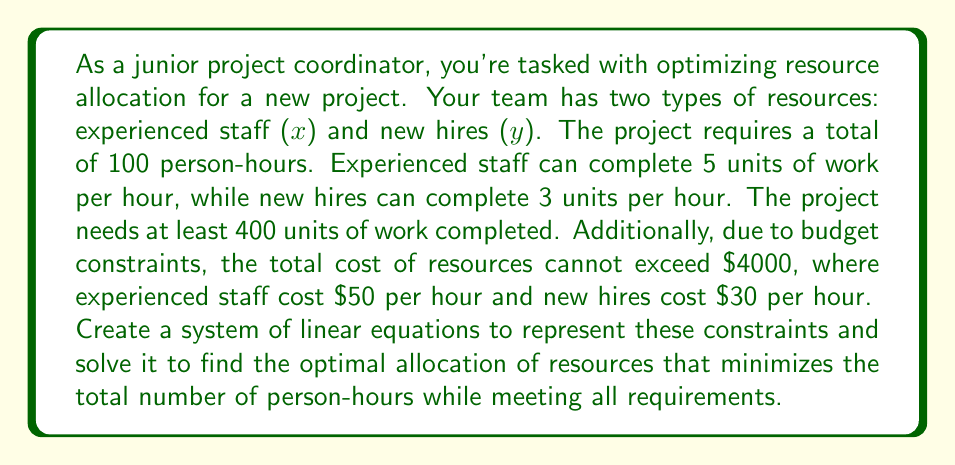Can you solve this math problem? Let's approach this step-by-step:

1) First, let's define our variables:
   $x$ = number of hours for experienced staff
   $y$ = number of hours for new hires

2) Now, let's create our system of linear equations based on the given constraints:

   a) Total person-hours: $x + y = 100$
   b) Work completed: $5x + 3y \geq 400$
   c) Budget constraint: $50x + 30y \leq 4000$

3) We want to minimize $x + y$ while satisfying these constraints. Let's solve this system graphically:

4) Rewrite the inequalities as equations:
   $5x + 3y = 400$
   $50x + 30y = 4000$

5) Solve these equations simultaneously:
   Multiply the first equation by 10: $50x + 30y = 4000$
   Subtract from the second equation: $20y = 0$
   Therefore, $y = 0$

6) Substitute $y = 0$ into $5x + 3y = 400$:
   $5x = 400$
   $x = 80$

7) Check if this solution satisfies all constraints:
   a) $80 + 0 = 80 \leq 100$ (Satisfies)
   b) $5(80) + 3(0) = 400 \geq 400$ (Satisfies)
   c) $50(80) + 30(0) = 4000 \leq 4000$ (Satisfies)

8) Therefore, the optimal solution is to use 80 hours of experienced staff and 0 hours of new hires.
Answer: The optimal resource allocation is 80 hours of experienced staff $(x = 80)$ and 0 hours of new hires $(y = 0)$, resulting in a total of 80 person-hours. 